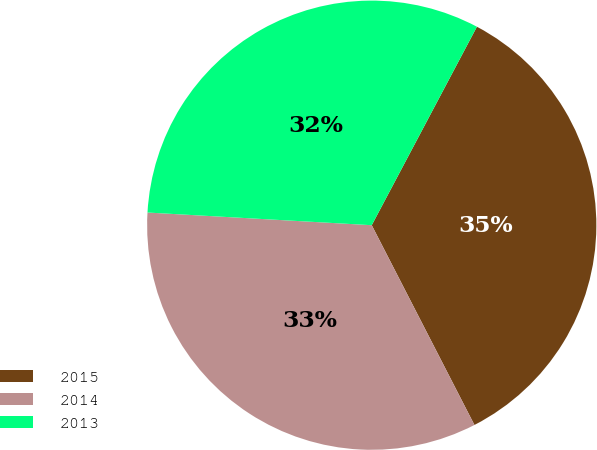Convert chart to OTSL. <chart><loc_0><loc_0><loc_500><loc_500><pie_chart><fcel>2015<fcel>2014<fcel>2013<nl><fcel>34.69%<fcel>33.46%<fcel>31.86%<nl></chart> 